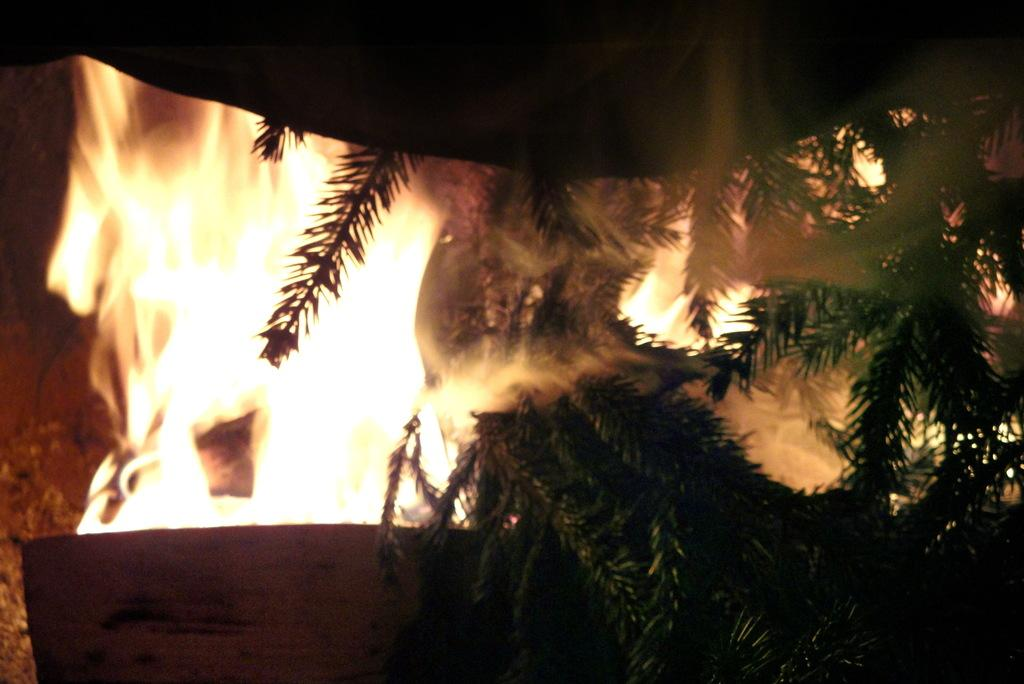What type of vegetation is present in the image? There is a group of trees in the image. What else can be seen in the image besides the trees? There is fire in the image. What type of plot is being developed in the image? There is no plot being developed in the image, as it is a static representation of trees and fire. 